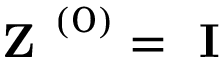<formula> <loc_0><loc_0><loc_500><loc_500>Z ^ { \left ( 0 \right ) } = I</formula> 